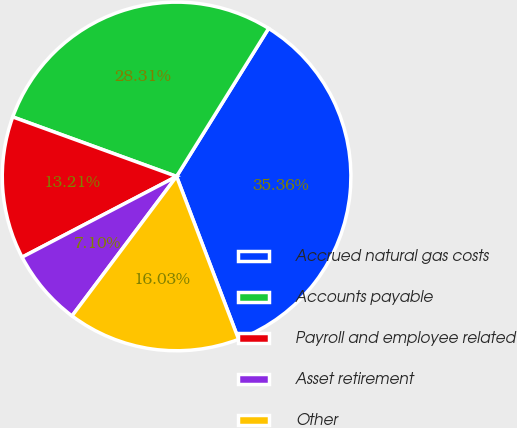Convert chart to OTSL. <chart><loc_0><loc_0><loc_500><loc_500><pie_chart><fcel>Accrued natural gas costs<fcel>Accounts payable<fcel>Payroll and employee related<fcel>Asset retirement<fcel>Other<nl><fcel>35.36%<fcel>28.31%<fcel>13.21%<fcel>7.1%<fcel>16.03%<nl></chart> 